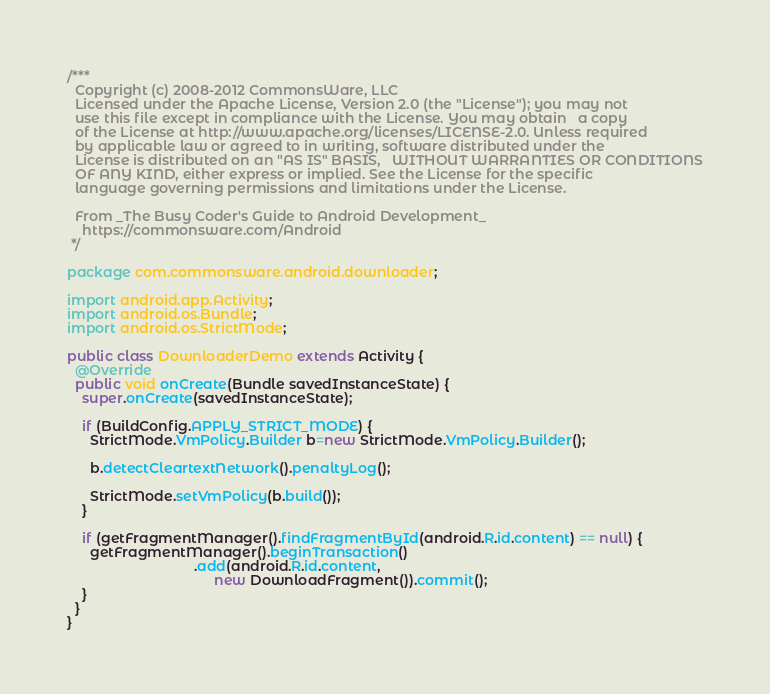Convert code to text. <code><loc_0><loc_0><loc_500><loc_500><_Java_>/***
  Copyright (c) 2008-2012 CommonsWare, LLC
  Licensed under the Apache License, Version 2.0 (the "License"); you may not
  use this file except in compliance with the License. You may obtain	a copy
  of the License at http://www.apache.org/licenses/LICENSE-2.0. Unless required
  by applicable law or agreed to in writing, software distributed under the
  License is distributed on an "AS IS" BASIS,	WITHOUT	WARRANTIES OR CONDITIONS
  OF ANY KIND, either express or implied. See the License for the specific
  language governing permissions and limitations under the License.
  
  From _The Busy Coder's Guide to Android Development_
    https://commonsware.com/Android
 */

package com.commonsware.android.downloader;

import android.app.Activity;
import android.os.Bundle;
import android.os.StrictMode;

public class DownloaderDemo extends Activity {
  @Override
  public void onCreate(Bundle savedInstanceState) {
    super.onCreate(savedInstanceState);

    if (BuildConfig.APPLY_STRICT_MODE) {
      StrictMode.VmPolicy.Builder b=new StrictMode.VmPolicy.Builder();

      b.detectCleartextNetwork().penaltyLog();

      StrictMode.setVmPolicy(b.build());
    }

    if (getFragmentManager().findFragmentById(android.R.id.content) == null) {
      getFragmentManager().beginTransaction()
                                 .add(android.R.id.content,
                                      new DownloadFragment()).commit();
    }
  }
}
</code> 